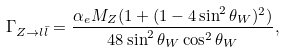<formula> <loc_0><loc_0><loc_500><loc_500>\Gamma _ { Z \to l { \bar { l } } } = { \frac { \alpha _ { e } M _ { Z } ( 1 + ( 1 - 4 \sin ^ { 2 } \theta _ { W } ) ^ { 2 } ) } { 4 8 \sin ^ { 2 } \theta _ { W } \cos ^ { 2 } \theta _ { W } } } ,</formula> 